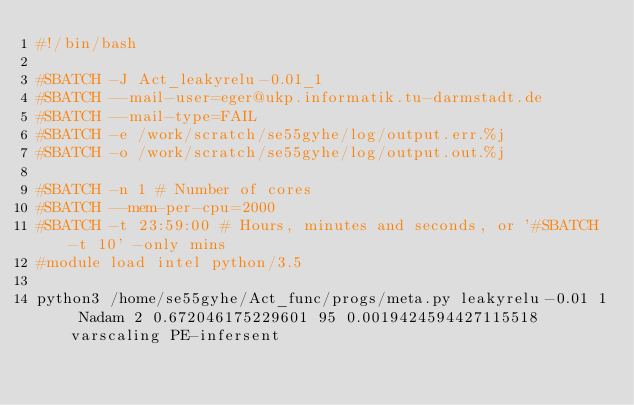Convert code to text. <code><loc_0><loc_0><loc_500><loc_500><_Bash_>#!/bin/bash
 
#SBATCH -J Act_leakyrelu-0.01_1
#SBATCH --mail-user=eger@ukp.informatik.tu-darmstadt.de
#SBATCH --mail-type=FAIL
#SBATCH -e /work/scratch/se55gyhe/log/output.err.%j
#SBATCH -o /work/scratch/se55gyhe/log/output.out.%j

#SBATCH -n 1 # Number of cores
#SBATCH --mem-per-cpu=2000
#SBATCH -t 23:59:00 # Hours, minutes and seconds, or '#SBATCH -t 10' -only mins
#module load intel python/3.5

python3 /home/se55gyhe/Act_func/progs/meta.py leakyrelu-0.01 1 Nadam 2 0.672046175229601 95 0.0019424594427115518 varscaling PE-infersent 

</code> 